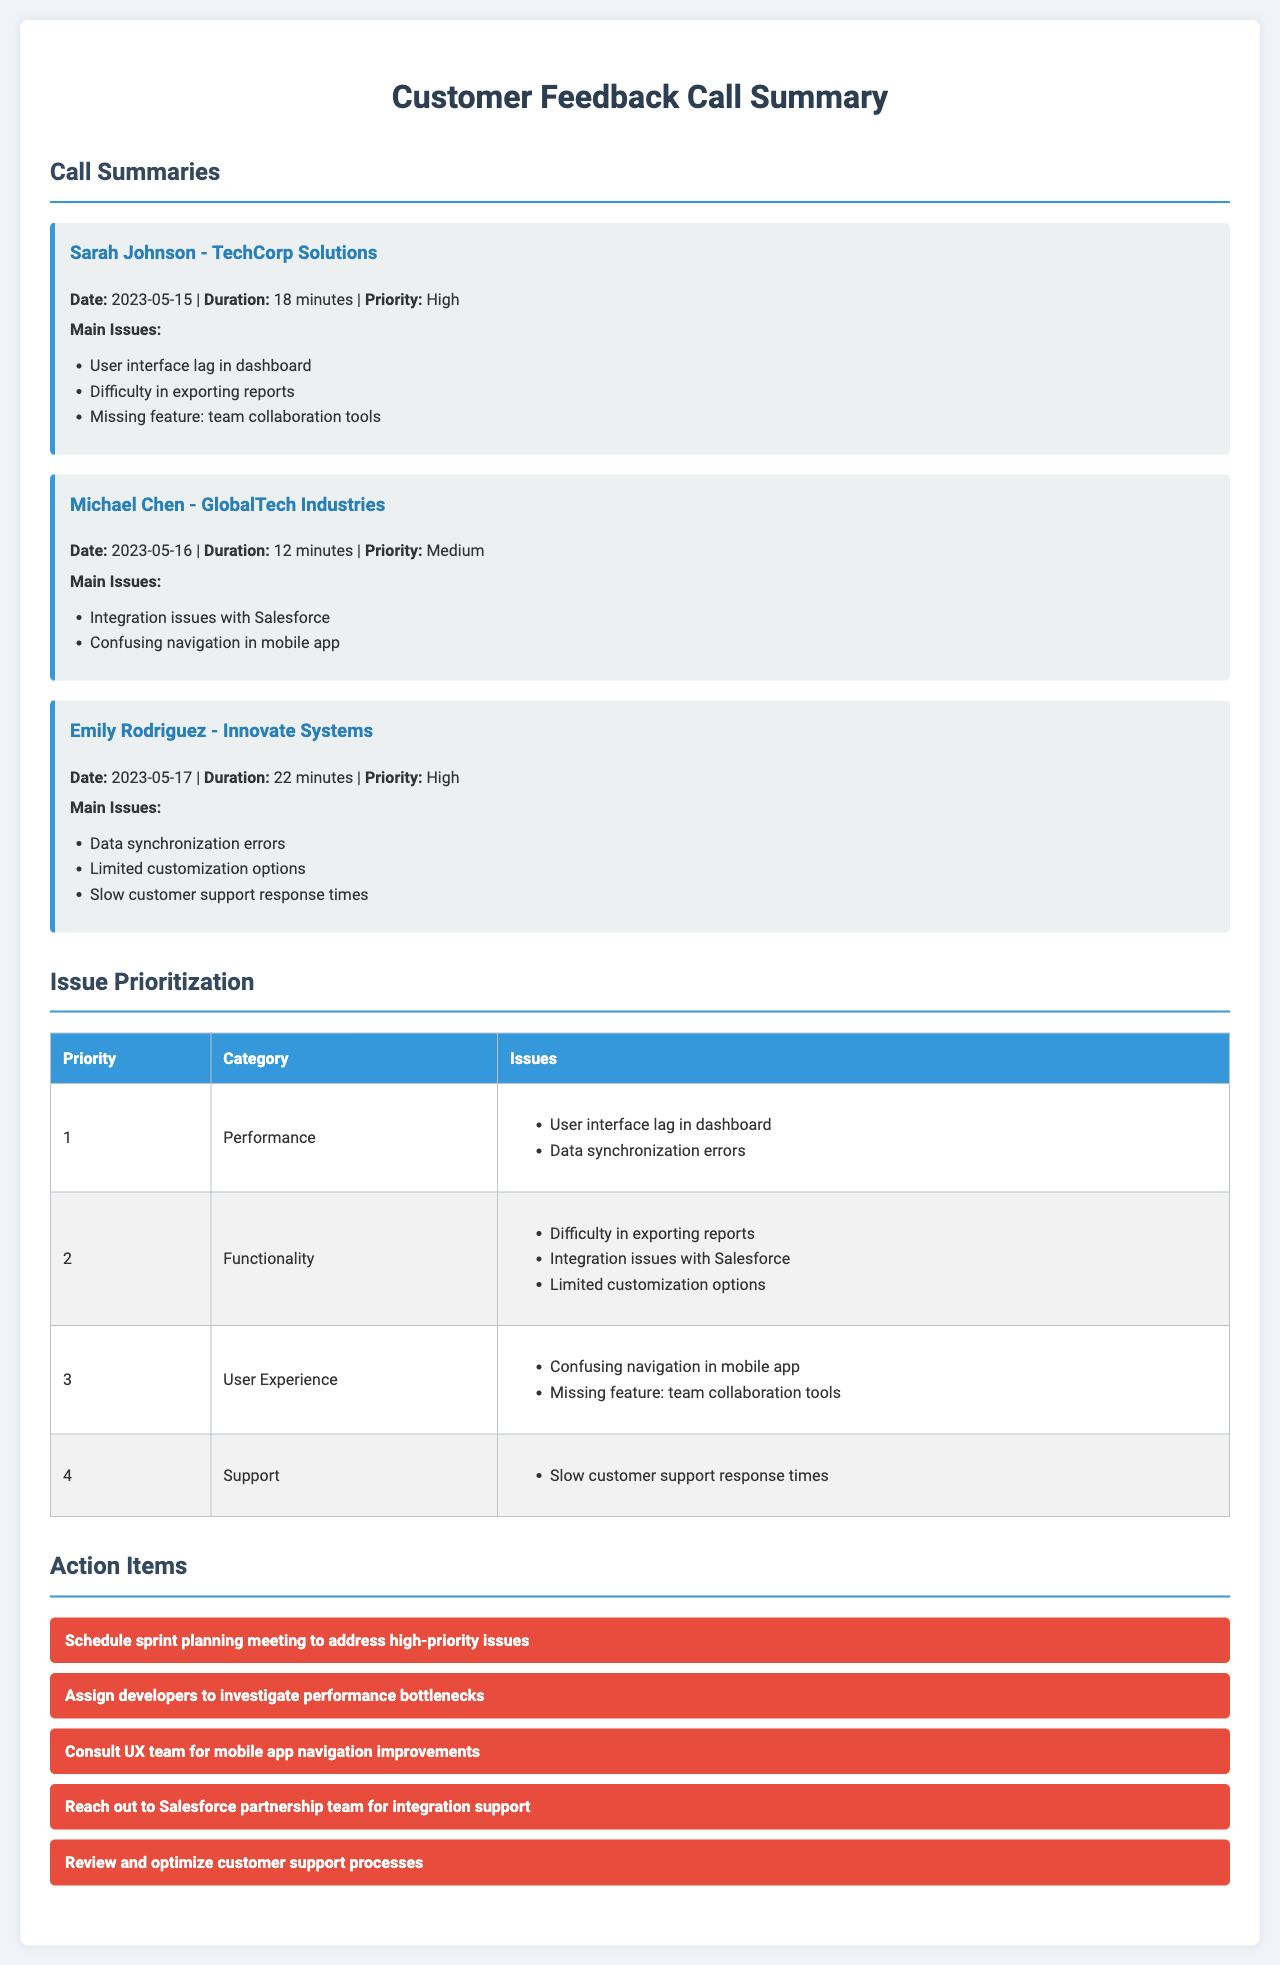What is the date of Sarah Johnson's call? The date of Sarah Johnson's call is listed under her call summary in the document.
Answer: 2023-05-15 What is the priority level for Emily Rodriguez's call? The priority level is mentioned directly in her call summary.
Answer: High How many issues were raised in the call with Michael Chen? The number of issues is determined by counting the bullet points listed in his call summary.
Answer: 2 Which feature is missing according to Sarah Johnson? The missing feature is specified in the list of main issues in Sarah Johnson's call summary.
Answer: Team collaboration tools What is the main issue related to support? The issue related to support is found in the categorization of issues in the document.
Answer: Slow customer support response times What is the main category for the highest priority issues? The highest priority issues are categorized under "Performance" in the issue prioritization table.
Answer: Performance Which company did Emily Rodriguez represent? The company name is provided in Emily Rodriguez's call summary section.
Answer: Innovate Systems How many action items are listed in the document? The number of action items can be counted from the bullet points in the action items section.
Answer: 5 